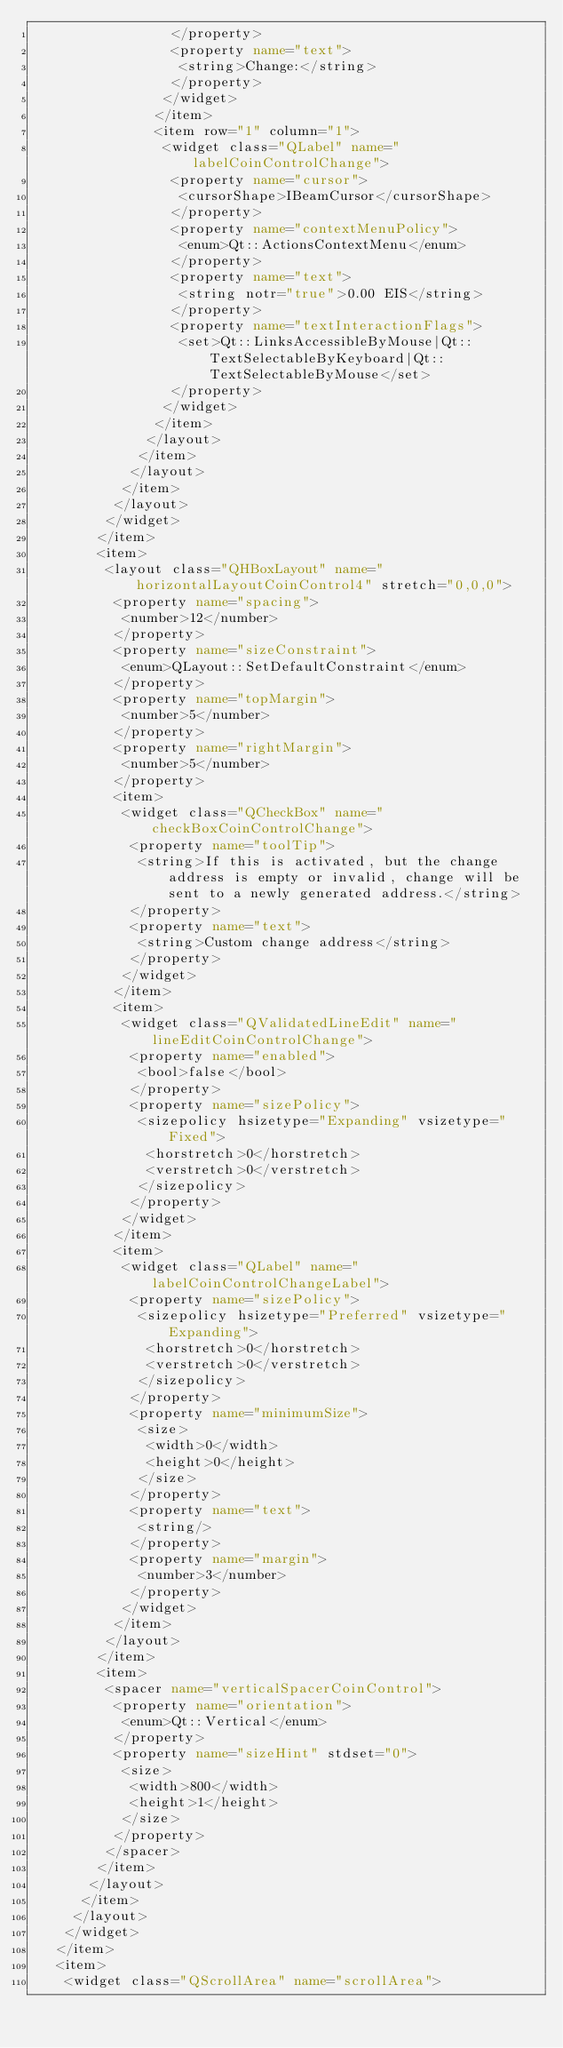Convert code to text. <code><loc_0><loc_0><loc_500><loc_500><_XML_>                 </property>
                 <property name="text">
                  <string>Change:</string>
                 </property>
                </widget>
               </item>
               <item row="1" column="1">
                <widget class="QLabel" name="labelCoinControlChange">
                 <property name="cursor">
                  <cursorShape>IBeamCursor</cursorShape>
                 </property>
                 <property name="contextMenuPolicy">
                  <enum>Qt::ActionsContextMenu</enum>
                 </property>
                 <property name="text">
                  <string notr="true">0.00 EIS</string>
                 </property>
                 <property name="textInteractionFlags">
                  <set>Qt::LinksAccessibleByMouse|Qt::TextSelectableByKeyboard|Qt::TextSelectableByMouse</set>
                 </property>
                </widget>
               </item>
              </layout>
             </item>
            </layout>
           </item>
          </layout>
         </widget>
        </item>
        <item>
         <layout class="QHBoxLayout" name="horizontalLayoutCoinControl4" stretch="0,0,0">
          <property name="spacing">
           <number>12</number>
          </property>
          <property name="sizeConstraint">
           <enum>QLayout::SetDefaultConstraint</enum>
          </property>
          <property name="topMargin">
           <number>5</number>
          </property>
          <property name="rightMargin">
           <number>5</number>
          </property>
          <item>
           <widget class="QCheckBox" name="checkBoxCoinControlChange">
            <property name="toolTip">
             <string>If this is activated, but the change address is empty or invalid, change will be sent to a newly generated address.</string>
            </property>
            <property name="text">
             <string>Custom change address</string>
            </property>
           </widget>
          </item>
          <item>
           <widget class="QValidatedLineEdit" name="lineEditCoinControlChange">
            <property name="enabled">
             <bool>false</bool>
            </property>
            <property name="sizePolicy">
             <sizepolicy hsizetype="Expanding" vsizetype="Fixed">
              <horstretch>0</horstretch>
              <verstretch>0</verstretch>
             </sizepolicy>
            </property>
           </widget>
          </item>
          <item>
           <widget class="QLabel" name="labelCoinControlChangeLabel">
            <property name="sizePolicy">
             <sizepolicy hsizetype="Preferred" vsizetype="Expanding">
              <horstretch>0</horstretch>
              <verstretch>0</verstretch>
             </sizepolicy>
            </property>
            <property name="minimumSize">
             <size>
              <width>0</width>
              <height>0</height>
             </size>
            </property>
            <property name="text">
             <string/>
            </property>
            <property name="margin">
             <number>3</number>
            </property>
           </widget>
          </item>
         </layout>
        </item>
        <item>
         <spacer name="verticalSpacerCoinControl">
          <property name="orientation">
           <enum>Qt::Vertical</enum>
          </property>
          <property name="sizeHint" stdset="0">
           <size>
            <width>800</width>
            <height>1</height>
           </size>
          </property>
         </spacer>
        </item>
       </layout>
      </item>
     </layout>
    </widget>
   </item>
   <item>
    <widget class="QScrollArea" name="scrollArea"></code> 